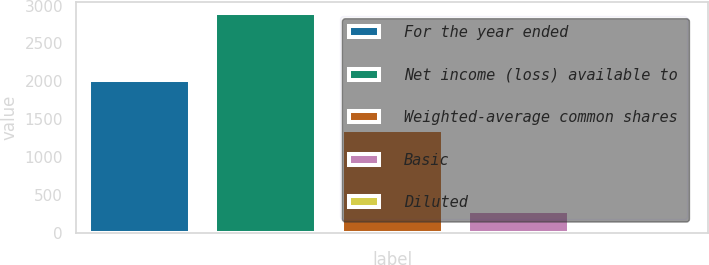Convert chart to OTSL. <chart><loc_0><loc_0><loc_500><loc_500><bar_chart><fcel>For the year ended<fcel>Net income (loss) available to<fcel>Weighted-average common shares<fcel>Basic<fcel>Diluted<nl><fcel>2015<fcel>2896<fcel>1359.65<fcel>292.12<fcel>2.47<nl></chart> 